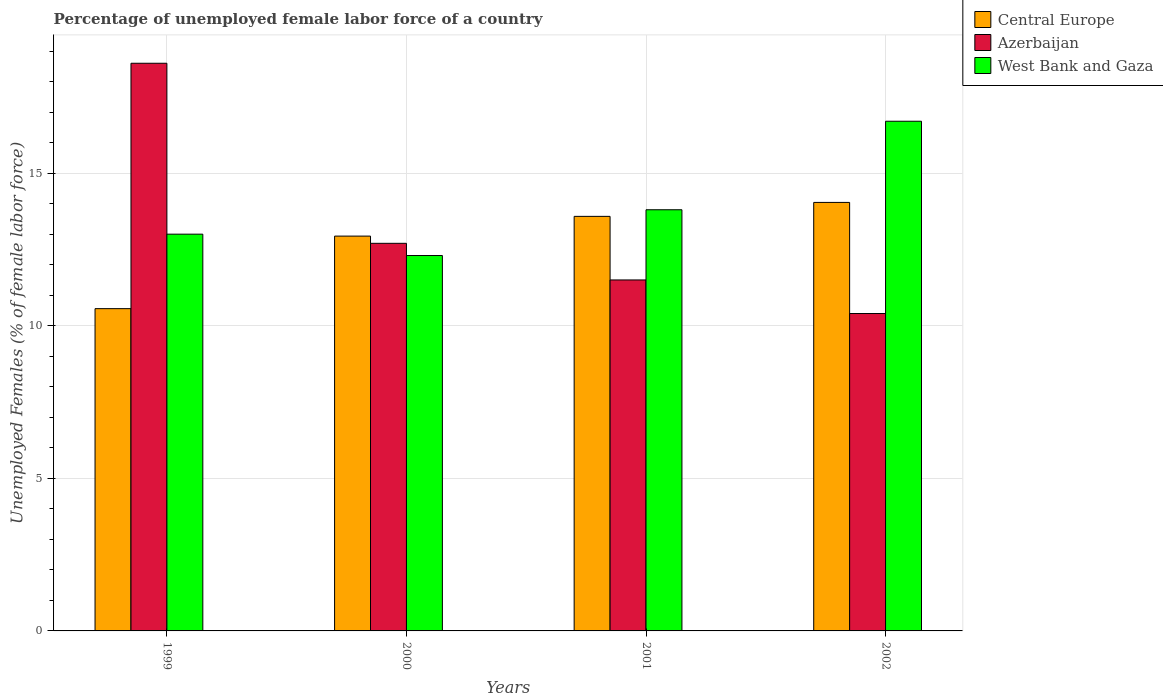How many different coloured bars are there?
Offer a terse response. 3. How many groups of bars are there?
Offer a terse response. 4. How many bars are there on the 4th tick from the right?
Provide a short and direct response. 3. What is the label of the 3rd group of bars from the left?
Offer a terse response. 2001. Across all years, what is the maximum percentage of unemployed female labor force in Azerbaijan?
Give a very brief answer. 18.6. Across all years, what is the minimum percentage of unemployed female labor force in West Bank and Gaza?
Ensure brevity in your answer.  12.3. In which year was the percentage of unemployed female labor force in Azerbaijan minimum?
Your answer should be compact. 2002. What is the total percentage of unemployed female labor force in Central Europe in the graph?
Offer a very short reply. 51.12. What is the difference between the percentage of unemployed female labor force in Central Europe in 1999 and that in 2000?
Offer a very short reply. -2.38. What is the difference between the percentage of unemployed female labor force in Azerbaijan in 2000 and the percentage of unemployed female labor force in West Bank and Gaza in 2002?
Provide a succinct answer. -4. What is the average percentage of unemployed female labor force in West Bank and Gaza per year?
Keep it short and to the point. 13.95. In the year 2001, what is the difference between the percentage of unemployed female labor force in Central Europe and percentage of unemployed female labor force in Azerbaijan?
Make the answer very short. 2.08. What is the ratio of the percentage of unemployed female labor force in West Bank and Gaza in 1999 to that in 2000?
Provide a short and direct response. 1.06. Is the percentage of unemployed female labor force in West Bank and Gaza in 2000 less than that in 2001?
Provide a succinct answer. Yes. What is the difference between the highest and the second highest percentage of unemployed female labor force in Azerbaijan?
Ensure brevity in your answer.  5.9. What is the difference between the highest and the lowest percentage of unemployed female labor force in West Bank and Gaza?
Provide a short and direct response. 4.4. Is the sum of the percentage of unemployed female labor force in West Bank and Gaza in 1999 and 2000 greater than the maximum percentage of unemployed female labor force in Azerbaijan across all years?
Provide a short and direct response. Yes. What does the 3rd bar from the left in 2002 represents?
Provide a short and direct response. West Bank and Gaza. What does the 1st bar from the right in 1999 represents?
Offer a very short reply. West Bank and Gaza. Is it the case that in every year, the sum of the percentage of unemployed female labor force in Central Europe and percentage of unemployed female labor force in Azerbaijan is greater than the percentage of unemployed female labor force in West Bank and Gaza?
Ensure brevity in your answer.  Yes. How many bars are there?
Make the answer very short. 12. How many years are there in the graph?
Provide a short and direct response. 4. What is the difference between two consecutive major ticks on the Y-axis?
Provide a short and direct response. 5. Where does the legend appear in the graph?
Your answer should be very brief. Top right. How many legend labels are there?
Ensure brevity in your answer.  3. How are the legend labels stacked?
Provide a succinct answer. Vertical. What is the title of the graph?
Your answer should be compact. Percentage of unemployed female labor force of a country. Does "Romania" appear as one of the legend labels in the graph?
Your response must be concise. No. What is the label or title of the X-axis?
Offer a very short reply. Years. What is the label or title of the Y-axis?
Offer a very short reply. Unemployed Females (% of female labor force). What is the Unemployed Females (% of female labor force) in Central Europe in 1999?
Your response must be concise. 10.56. What is the Unemployed Females (% of female labor force) of Azerbaijan in 1999?
Offer a terse response. 18.6. What is the Unemployed Females (% of female labor force) in West Bank and Gaza in 1999?
Offer a terse response. 13. What is the Unemployed Females (% of female labor force) of Central Europe in 2000?
Your answer should be compact. 12.94. What is the Unemployed Females (% of female labor force) in Azerbaijan in 2000?
Give a very brief answer. 12.7. What is the Unemployed Females (% of female labor force) in West Bank and Gaza in 2000?
Ensure brevity in your answer.  12.3. What is the Unemployed Females (% of female labor force) of Central Europe in 2001?
Provide a succinct answer. 13.58. What is the Unemployed Females (% of female labor force) of West Bank and Gaza in 2001?
Offer a terse response. 13.8. What is the Unemployed Females (% of female labor force) of Central Europe in 2002?
Provide a succinct answer. 14.04. What is the Unemployed Females (% of female labor force) of Azerbaijan in 2002?
Ensure brevity in your answer.  10.4. What is the Unemployed Females (% of female labor force) of West Bank and Gaza in 2002?
Provide a succinct answer. 16.7. Across all years, what is the maximum Unemployed Females (% of female labor force) in Central Europe?
Provide a short and direct response. 14.04. Across all years, what is the maximum Unemployed Females (% of female labor force) in Azerbaijan?
Give a very brief answer. 18.6. Across all years, what is the maximum Unemployed Females (% of female labor force) in West Bank and Gaza?
Keep it short and to the point. 16.7. Across all years, what is the minimum Unemployed Females (% of female labor force) of Central Europe?
Make the answer very short. 10.56. Across all years, what is the minimum Unemployed Females (% of female labor force) in Azerbaijan?
Ensure brevity in your answer.  10.4. Across all years, what is the minimum Unemployed Females (% of female labor force) in West Bank and Gaza?
Offer a very short reply. 12.3. What is the total Unemployed Females (% of female labor force) in Central Europe in the graph?
Ensure brevity in your answer.  51.12. What is the total Unemployed Females (% of female labor force) of Azerbaijan in the graph?
Give a very brief answer. 53.2. What is the total Unemployed Females (% of female labor force) in West Bank and Gaza in the graph?
Provide a succinct answer. 55.8. What is the difference between the Unemployed Females (% of female labor force) of Central Europe in 1999 and that in 2000?
Give a very brief answer. -2.38. What is the difference between the Unemployed Females (% of female labor force) in Azerbaijan in 1999 and that in 2000?
Make the answer very short. 5.9. What is the difference between the Unemployed Females (% of female labor force) of West Bank and Gaza in 1999 and that in 2000?
Offer a terse response. 0.7. What is the difference between the Unemployed Females (% of female labor force) of Central Europe in 1999 and that in 2001?
Give a very brief answer. -3.02. What is the difference between the Unemployed Females (% of female labor force) of Central Europe in 1999 and that in 2002?
Provide a succinct answer. -3.48. What is the difference between the Unemployed Females (% of female labor force) of Azerbaijan in 1999 and that in 2002?
Ensure brevity in your answer.  8.2. What is the difference between the Unemployed Females (% of female labor force) in Central Europe in 2000 and that in 2001?
Your answer should be very brief. -0.65. What is the difference between the Unemployed Females (% of female labor force) in Azerbaijan in 2000 and that in 2001?
Give a very brief answer. 1.2. What is the difference between the Unemployed Females (% of female labor force) in Central Europe in 2000 and that in 2002?
Ensure brevity in your answer.  -1.1. What is the difference between the Unemployed Females (% of female labor force) of Central Europe in 2001 and that in 2002?
Keep it short and to the point. -0.46. What is the difference between the Unemployed Females (% of female labor force) of Azerbaijan in 2001 and that in 2002?
Provide a succinct answer. 1.1. What is the difference between the Unemployed Females (% of female labor force) of Central Europe in 1999 and the Unemployed Females (% of female labor force) of Azerbaijan in 2000?
Provide a succinct answer. -2.14. What is the difference between the Unemployed Females (% of female labor force) of Central Europe in 1999 and the Unemployed Females (% of female labor force) of West Bank and Gaza in 2000?
Ensure brevity in your answer.  -1.74. What is the difference between the Unemployed Females (% of female labor force) in Central Europe in 1999 and the Unemployed Females (% of female labor force) in Azerbaijan in 2001?
Give a very brief answer. -0.94. What is the difference between the Unemployed Females (% of female labor force) in Central Europe in 1999 and the Unemployed Females (% of female labor force) in West Bank and Gaza in 2001?
Ensure brevity in your answer.  -3.24. What is the difference between the Unemployed Females (% of female labor force) in Azerbaijan in 1999 and the Unemployed Females (% of female labor force) in West Bank and Gaza in 2001?
Provide a succinct answer. 4.8. What is the difference between the Unemployed Females (% of female labor force) in Central Europe in 1999 and the Unemployed Females (% of female labor force) in Azerbaijan in 2002?
Your answer should be compact. 0.16. What is the difference between the Unemployed Females (% of female labor force) of Central Europe in 1999 and the Unemployed Females (% of female labor force) of West Bank and Gaza in 2002?
Give a very brief answer. -6.14. What is the difference between the Unemployed Females (% of female labor force) of Central Europe in 2000 and the Unemployed Females (% of female labor force) of Azerbaijan in 2001?
Offer a very short reply. 1.44. What is the difference between the Unemployed Females (% of female labor force) in Central Europe in 2000 and the Unemployed Females (% of female labor force) in West Bank and Gaza in 2001?
Offer a very short reply. -0.86. What is the difference between the Unemployed Females (% of female labor force) of Azerbaijan in 2000 and the Unemployed Females (% of female labor force) of West Bank and Gaza in 2001?
Offer a terse response. -1.1. What is the difference between the Unemployed Females (% of female labor force) of Central Europe in 2000 and the Unemployed Females (% of female labor force) of Azerbaijan in 2002?
Your response must be concise. 2.54. What is the difference between the Unemployed Females (% of female labor force) in Central Europe in 2000 and the Unemployed Females (% of female labor force) in West Bank and Gaza in 2002?
Provide a succinct answer. -3.76. What is the difference between the Unemployed Females (% of female labor force) in Azerbaijan in 2000 and the Unemployed Females (% of female labor force) in West Bank and Gaza in 2002?
Ensure brevity in your answer.  -4. What is the difference between the Unemployed Females (% of female labor force) of Central Europe in 2001 and the Unemployed Females (% of female labor force) of Azerbaijan in 2002?
Your answer should be compact. 3.18. What is the difference between the Unemployed Females (% of female labor force) in Central Europe in 2001 and the Unemployed Females (% of female labor force) in West Bank and Gaza in 2002?
Make the answer very short. -3.12. What is the difference between the Unemployed Females (% of female labor force) of Azerbaijan in 2001 and the Unemployed Females (% of female labor force) of West Bank and Gaza in 2002?
Offer a very short reply. -5.2. What is the average Unemployed Females (% of female labor force) of Central Europe per year?
Ensure brevity in your answer.  12.78. What is the average Unemployed Females (% of female labor force) of Azerbaijan per year?
Give a very brief answer. 13.3. What is the average Unemployed Females (% of female labor force) in West Bank and Gaza per year?
Keep it short and to the point. 13.95. In the year 1999, what is the difference between the Unemployed Females (% of female labor force) in Central Europe and Unemployed Females (% of female labor force) in Azerbaijan?
Keep it short and to the point. -8.04. In the year 1999, what is the difference between the Unemployed Females (% of female labor force) in Central Europe and Unemployed Females (% of female labor force) in West Bank and Gaza?
Offer a terse response. -2.44. In the year 1999, what is the difference between the Unemployed Females (% of female labor force) of Azerbaijan and Unemployed Females (% of female labor force) of West Bank and Gaza?
Offer a very short reply. 5.6. In the year 2000, what is the difference between the Unemployed Females (% of female labor force) of Central Europe and Unemployed Females (% of female labor force) of Azerbaijan?
Give a very brief answer. 0.24. In the year 2000, what is the difference between the Unemployed Females (% of female labor force) in Central Europe and Unemployed Females (% of female labor force) in West Bank and Gaza?
Provide a succinct answer. 0.64. In the year 2000, what is the difference between the Unemployed Females (% of female labor force) of Azerbaijan and Unemployed Females (% of female labor force) of West Bank and Gaza?
Your answer should be very brief. 0.4. In the year 2001, what is the difference between the Unemployed Females (% of female labor force) of Central Europe and Unemployed Females (% of female labor force) of Azerbaijan?
Provide a short and direct response. 2.08. In the year 2001, what is the difference between the Unemployed Females (% of female labor force) in Central Europe and Unemployed Females (% of female labor force) in West Bank and Gaza?
Provide a short and direct response. -0.22. In the year 2001, what is the difference between the Unemployed Females (% of female labor force) of Azerbaijan and Unemployed Females (% of female labor force) of West Bank and Gaza?
Make the answer very short. -2.3. In the year 2002, what is the difference between the Unemployed Females (% of female labor force) of Central Europe and Unemployed Females (% of female labor force) of Azerbaijan?
Offer a very short reply. 3.64. In the year 2002, what is the difference between the Unemployed Females (% of female labor force) in Central Europe and Unemployed Females (% of female labor force) in West Bank and Gaza?
Offer a terse response. -2.66. In the year 2002, what is the difference between the Unemployed Females (% of female labor force) of Azerbaijan and Unemployed Females (% of female labor force) of West Bank and Gaza?
Make the answer very short. -6.3. What is the ratio of the Unemployed Females (% of female labor force) of Central Europe in 1999 to that in 2000?
Your answer should be compact. 0.82. What is the ratio of the Unemployed Females (% of female labor force) in Azerbaijan in 1999 to that in 2000?
Offer a very short reply. 1.46. What is the ratio of the Unemployed Females (% of female labor force) of West Bank and Gaza in 1999 to that in 2000?
Your answer should be very brief. 1.06. What is the ratio of the Unemployed Females (% of female labor force) in Central Europe in 1999 to that in 2001?
Ensure brevity in your answer.  0.78. What is the ratio of the Unemployed Females (% of female labor force) of Azerbaijan in 1999 to that in 2001?
Offer a very short reply. 1.62. What is the ratio of the Unemployed Females (% of female labor force) in West Bank and Gaza in 1999 to that in 2001?
Your response must be concise. 0.94. What is the ratio of the Unemployed Females (% of female labor force) in Central Europe in 1999 to that in 2002?
Make the answer very short. 0.75. What is the ratio of the Unemployed Females (% of female labor force) of Azerbaijan in 1999 to that in 2002?
Your answer should be very brief. 1.79. What is the ratio of the Unemployed Females (% of female labor force) in West Bank and Gaza in 1999 to that in 2002?
Keep it short and to the point. 0.78. What is the ratio of the Unemployed Females (% of female labor force) of Azerbaijan in 2000 to that in 2001?
Offer a very short reply. 1.1. What is the ratio of the Unemployed Females (% of female labor force) in West Bank and Gaza in 2000 to that in 2001?
Your answer should be very brief. 0.89. What is the ratio of the Unemployed Females (% of female labor force) in Central Europe in 2000 to that in 2002?
Ensure brevity in your answer.  0.92. What is the ratio of the Unemployed Females (% of female labor force) in Azerbaijan in 2000 to that in 2002?
Keep it short and to the point. 1.22. What is the ratio of the Unemployed Females (% of female labor force) of West Bank and Gaza in 2000 to that in 2002?
Offer a very short reply. 0.74. What is the ratio of the Unemployed Females (% of female labor force) of Central Europe in 2001 to that in 2002?
Offer a terse response. 0.97. What is the ratio of the Unemployed Females (% of female labor force) of Azerbaijan in 2001 to that in 2002?
Ensure brevity in your answer.  1.11. What is the ratio of the Unemployed Females (% of female labor force) of West Bank and Gaza in 2001 to that in 2002?
Give a very brief answer. 0.83. What is the difference between the highest and the second highest Unemployed Females (% of female labor force) of Central Europe?
Make the answer very short. 0.46. What is the difference between the highest and the second highest Unemployed Females (% of female labor force) in Azerbaijan?
Offer a terse response. 5.9. What is the difference between the highest and the second highest Unemployed Females (% of female labor force) of West Bank and Gaza?
Keep it short and to the point. 2.9. What is the difference between the highest and the lowest Unemployed Females (% of female labor force) in Central Europe?
Offer a very short reply. 3.48. What is the difference between the highest and the lowest Unemployed Females (% of female labor force) in Azerbaijan?
Make the answer very short. 8.2. 